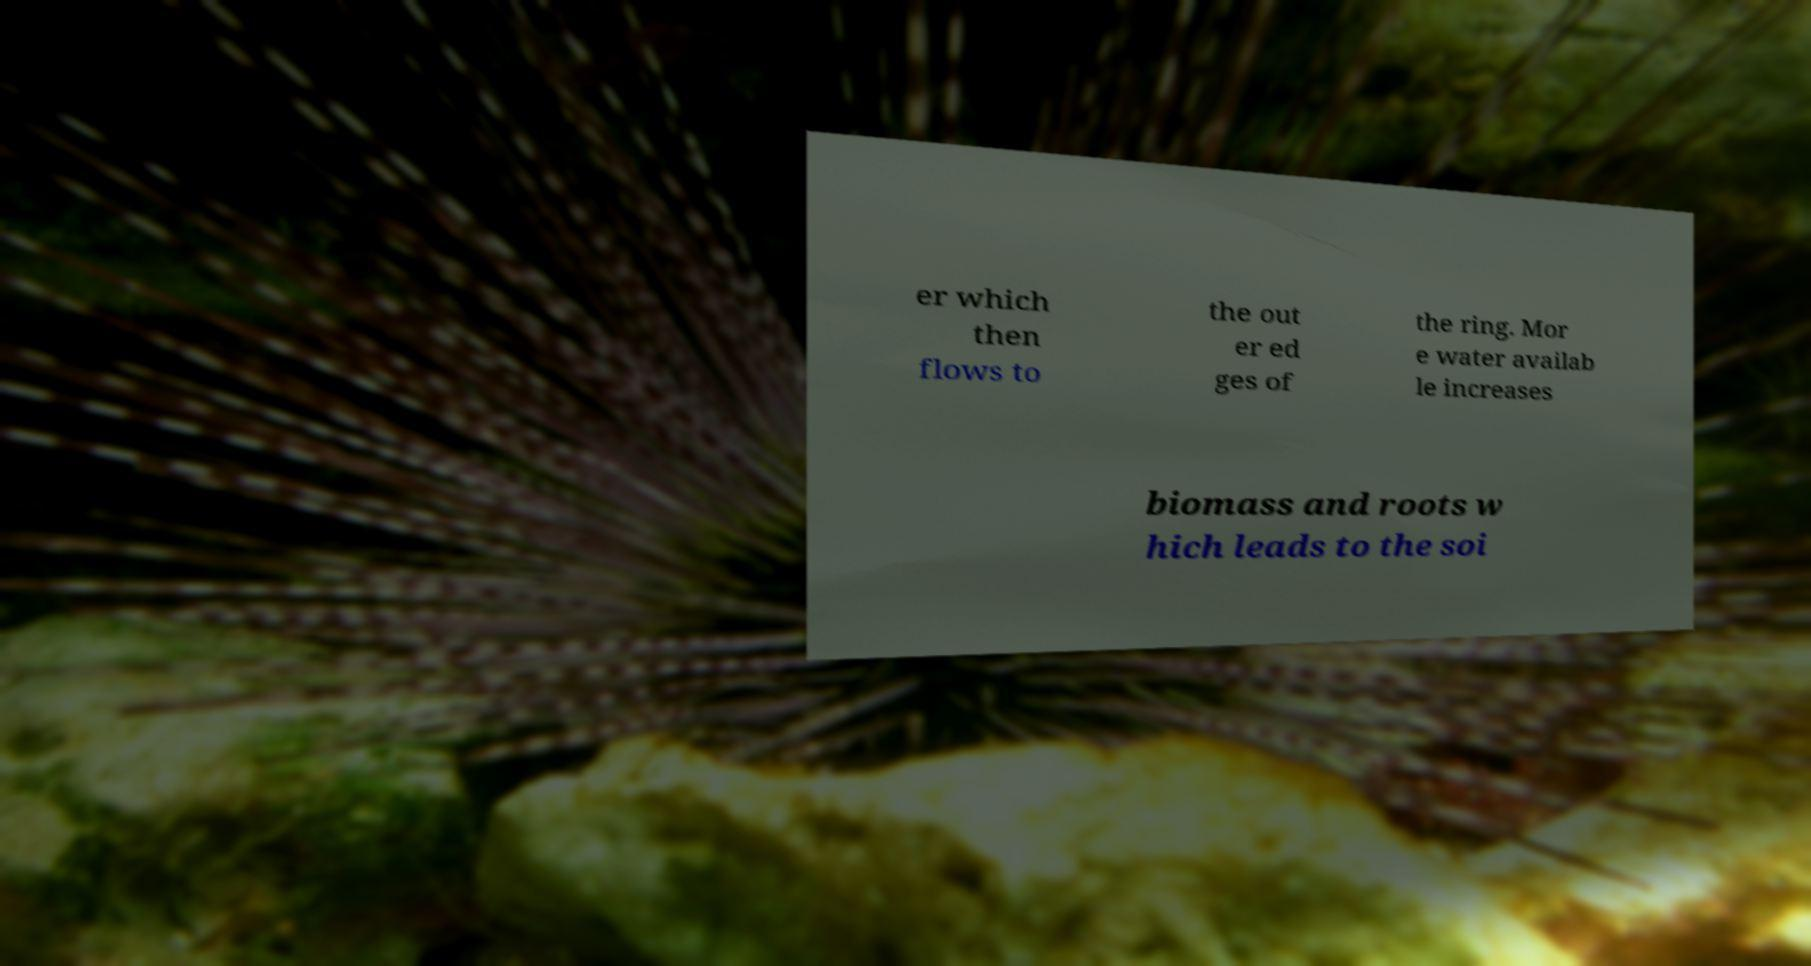Please identify and transcribe the text found in this image. er which then flows to the out er ed ges of the ring. Mor e water availab le increases biomass and roots w hich leads to the soi 